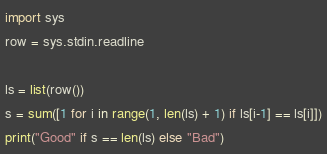<code> <loc_0><loc_0><loc_500><loc_500><_Python_>import sys
row = sys.stdin.readline
 
ls = list(row())
s = sum([1 for i in range(1, len(ls) + 1) if ls[i-1] == ls[i]])
print("Good" if s == len(ls) else "Bad")
</code> 